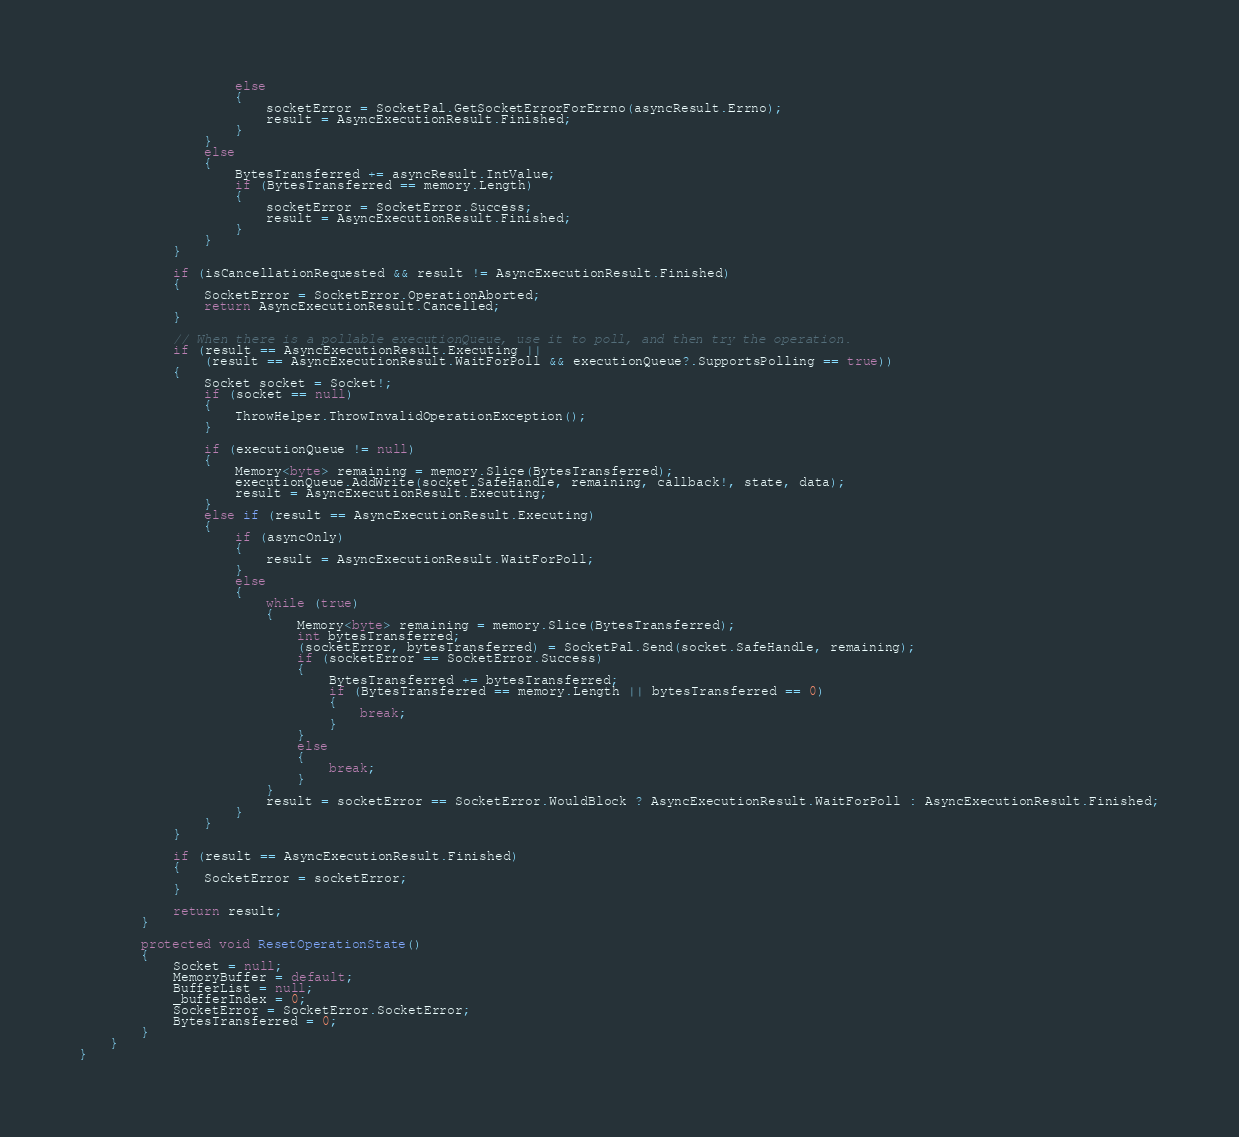<code> <loc_0><loc_0><loc_500><loc_500><_C#_>                    else
                    {
                        socketError = SocketPal.GetSocketErrorForErrno(asyncResult.Errno);
                        result = AsyncExecutionResult.Finished;
                    }
                }
                else
                {
                    BytesTransferred += asyncResult.IntValue;
                    if (BytesTransferred == memory.Length)
                    {
                        socketError = SocketError.Success;
                        result = AsyncExecutionResult.Finished;
                    }
                }
            }

            if (isCancellationRequested && result != AsyncExecutionResult.Finished)
            {
                SocketError = SocketError.OperationAborted;
                return AsyncExecutionResult.Cancelled;
            }

            // When there is a pollable executionQueue, use it to poll, and then try the operation.
            if (result == AsyncExecutionResult.Executing ||
                (result == AsyncExecutionResult.WaitForPoll && executionQueue?.SupportsPolling == true))
            {
                Socket socket = Socket!;
                if (socket == null)
                {
                    ThrowHelper.ThrowInvalidOperationException();
                }

                if (executionQueue != null)
                {
                    Memory<byte> remaining = memory.Slice(BytesTransferred);
                    executionQueue.AddWrite(socket.SafeHandle, remaining, callback!, state, data);
                    result = AsyncExecutionResult.Executing;
                }
                else if (result == AsyncExecutionResult.Executing)
                {
                    if (asyncOnly)
                    {
                        result = AsyncExecutionResult.WaitForPoll;
                    }
                    else
                    {
                        while (true)
                        {
                            Memory<byte> remaining = memory.Slice(BytesTransferred);
                            int bytesTransferred;
                            (socketError, bytesTransferred) = SocketPal.Send(socket.SafeHandle, remaining);
                            if (socketError == SocketError.Success)
                            {
                                BytesTransferred += bytesTransferred;
                                if (BytesTransferred == memory.Length || bytesTransferred == 0)
                                {
                                    break;
                                }
                            }
                            else
                            {
                                break;
                            }
                        }
                        result = socketError == SocketError.WouldBlock ? AsyncExecutionResult.WaitForPoll : AsyncExecutionResult.Finished;
                    }
                }
            }

            if (result == AsyncExecutionResult.Finished)
            {
                SocketError = socketError;
            }

            return result;
        }

        protected void ResetOperationState()
        {
            Socket = null;
            MemoryBuffer = default;
            BufferList = null;
            _bufferIndex = 0;
            SocketError = SocketError.SocketError;
            BytesTransferred = 0;
        }
    }
}</code> 